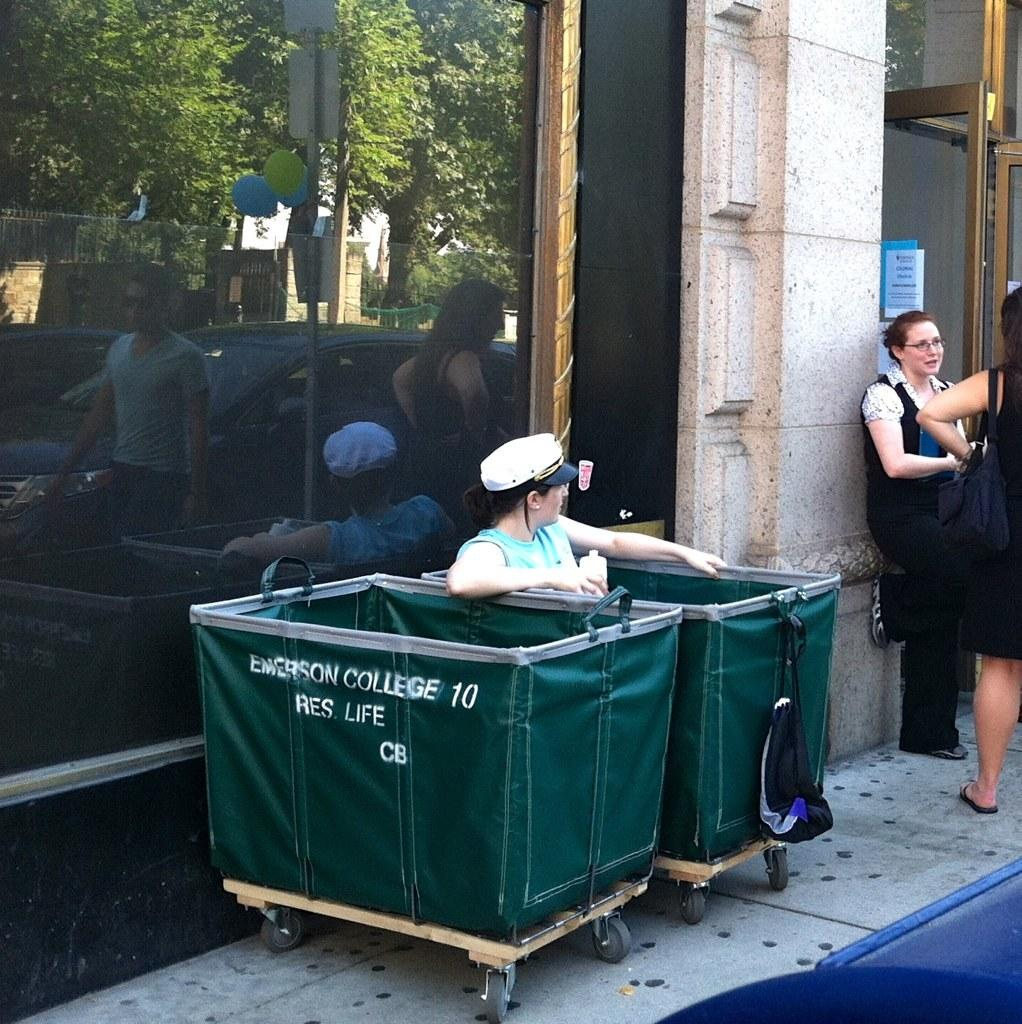<image>
Describe the image concisely. Woman sitting in a green bin that says the number 10 on it. 